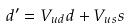Convert formula to latex. <formula><loc_0><loc_0><loc_500><loc_500>d ^ { \prime } = V _ { u d } d + V _ { u s } s</formula> 